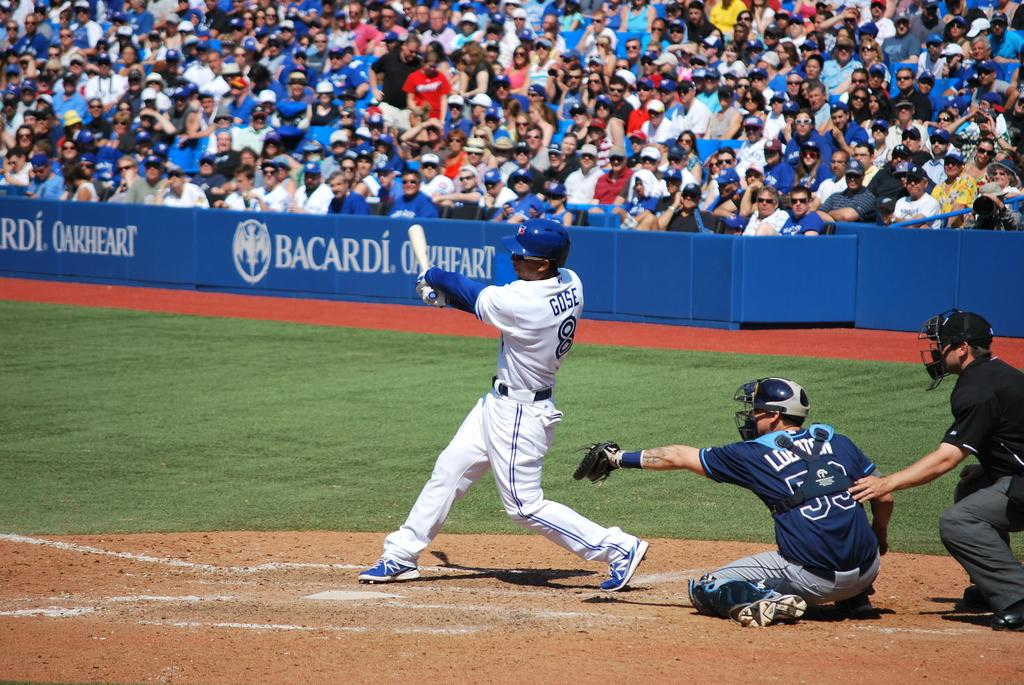<image>
Write a terse but informative summary of the picture. A man is batting with the name Gose on the back of his jersey. 